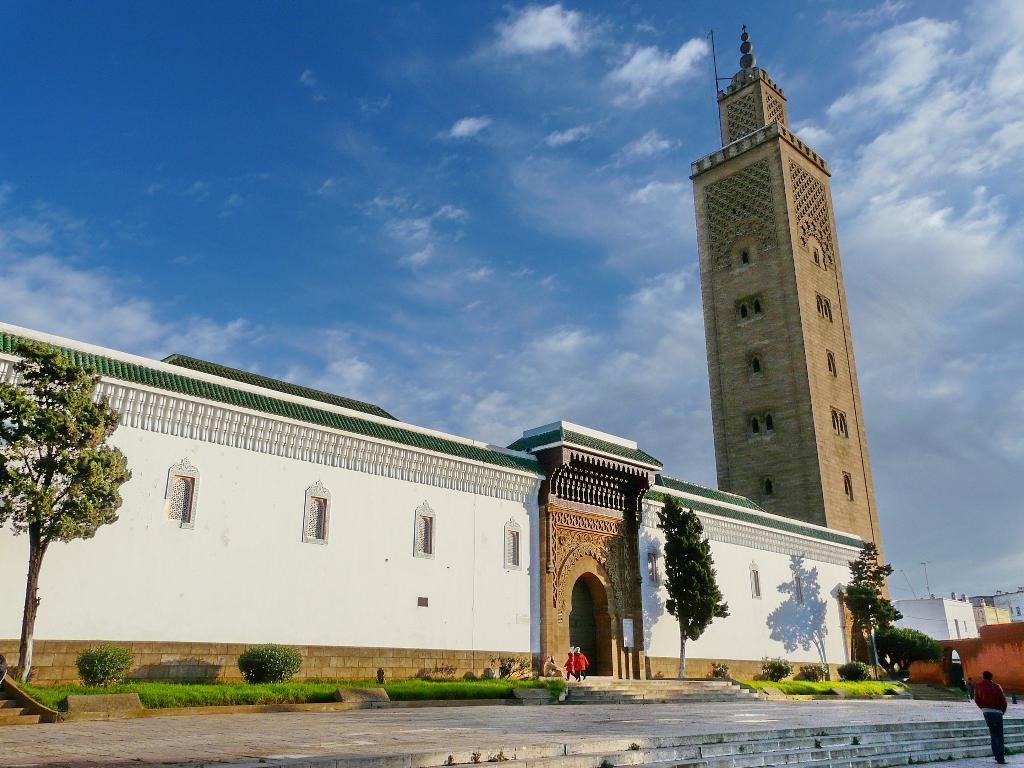Can you describe this image briefly? In this image I can see few stairs, few persons standing, some grass, few trees which are green in color and few buildings. In the background I can see the sky. 